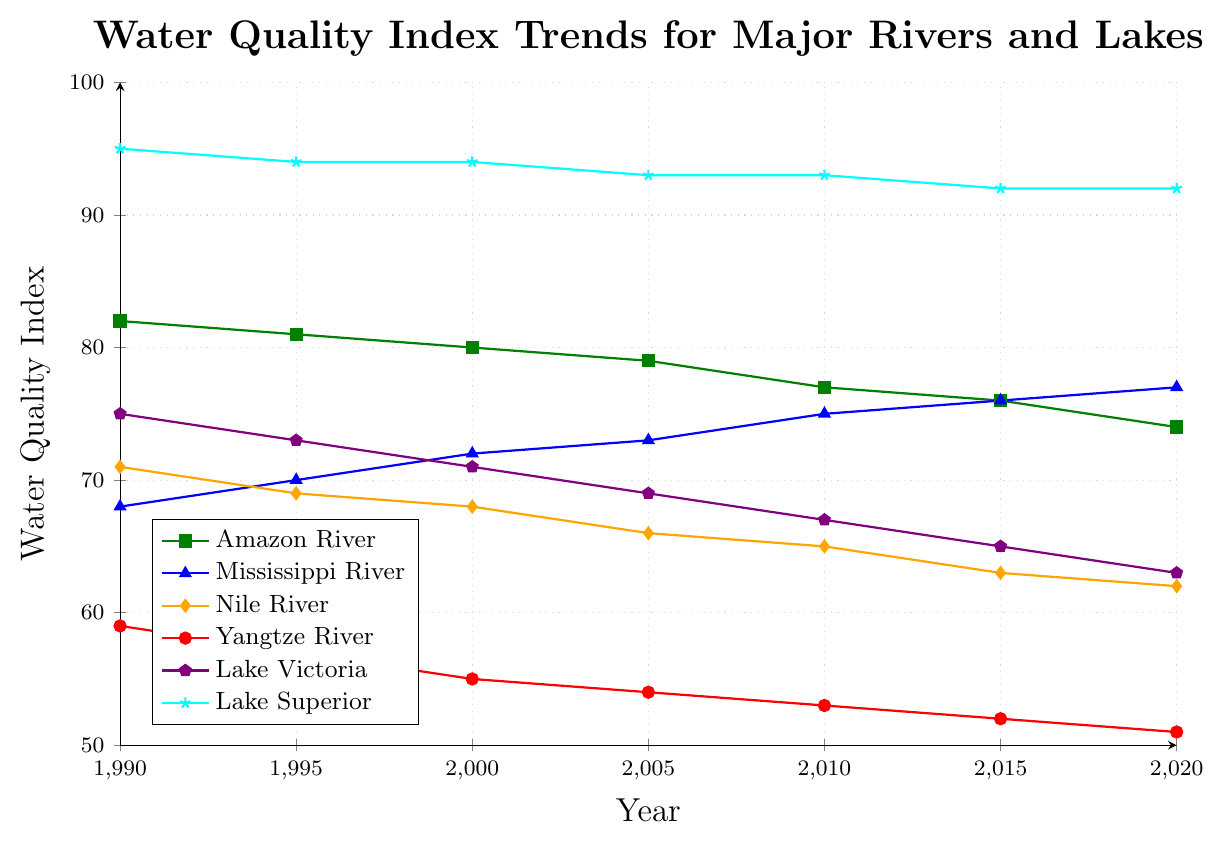What trend do you observe in the water quality index of the Amazon River between 1990 and 2020? From the figure, the water quality index of the Amazon River shows a decreasing trend over the period. In 1990, it started at 82 and gradually decreased to 74 by 2020.
Answer: Decreasing trend Which river shows an improving water quality index from 1990 to 2020? The Mississippi River shows an improving trend in its water quality index, increasing from 68 in 1990 to 77 in 2020.
Answer: Mississippi River How does the water quality index of Lake Superior in 2020 compare to that of the Amazon River? In 2020, the water quality index of Lake Superior is 92, whereas the Amazon River has a water quality index of 74. Lake Superior's index is thus higher.
Answer: Lake Superior's is higher Which water body has the highest water quality index across all years presented? By examining the plotted lines, Lake Superior consistently has the highest water quality index across all years presented, starting at 95 in 1990 and ending at 92 in 2020.
Answer: Lake Superior What is the average water quality index for the Nile River across the years presented? Add the water quality index values for the Nile River from the figure: (71 + 69 + 68 + 66 + 65 + 63 + 62) = 464. Divide by the number of data points (7 years), 464/7 ≈ 66.29.
Answer: 66.29 Which two rivers or lakes have the closest water quality indices in the year 2020? In 2020, the water quality indices are as follows: Amazon River (74), Mississippi River (77), Nile River (62), Yangtze River (51), Lake Victoria (63), and Lake Superior (92). The Nile River and Lake Victoria have the closest values at 62 and 63.
Answer: Nile River and Lake Victoria Compare the change in the water quality index of the Mississippi River to that of the Yangtze River from 1990 to 2020. The water quality index for the Mississippi River increased from 68 in 1990 to 77 in 2020, a change of +9. The index for the Yangtze River decreased from 59 in 1990 to 51 in 2020, a change of -8.
Answer: Mississippi increased by 9, Yangtze decreased by 8 Which year did the Nile River and Lake Victoria have the same water quality index, and what was that index? Both the Nile River and Lake Victoria had a water quality index of 71 in the year 2000.
Answer: 2000, 71 